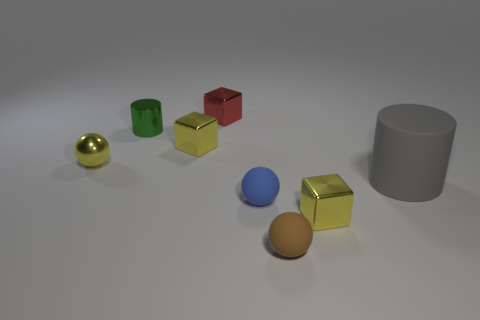What number of other red objects have the same shape as the tiny red thing?
Your response must be concise. 0. There is a blue thing that is the same material as the gray thing; what shape is it?
Offer a terse response. Sphere. How many purple things are tiny things or metallic cylinders?
Your answer should be very brief. 0. There is a blue ball; are there any tiny spheres in front of it?
Your answer should be compact. Yes. Does the metal thing in front of the large cylinder have the same shape as the red metal thing behind the blue matte object?
Ensure brevity in your answer.  Yes. There is a brown object that is the same shape as the blue matte thing; what is its material?
Give a very brief answer. Rubber. What number of cylinders are either green metallic things or red rubber things?
Offer a very short reply. 1. What number of small yellow blocks have the same material as the small green cylinder?
Keep it short and to the point. 2. Is the material of the block behind the tiny green metallic thing the same as the gray cylinder that is to the right of the red thing?
Ensure brevity in your answer.  No. What number of spheres are on the right side of the yellow metal cube to the left of the small red object to the right of the green cylinder?
Offer a very short reply. 2. 